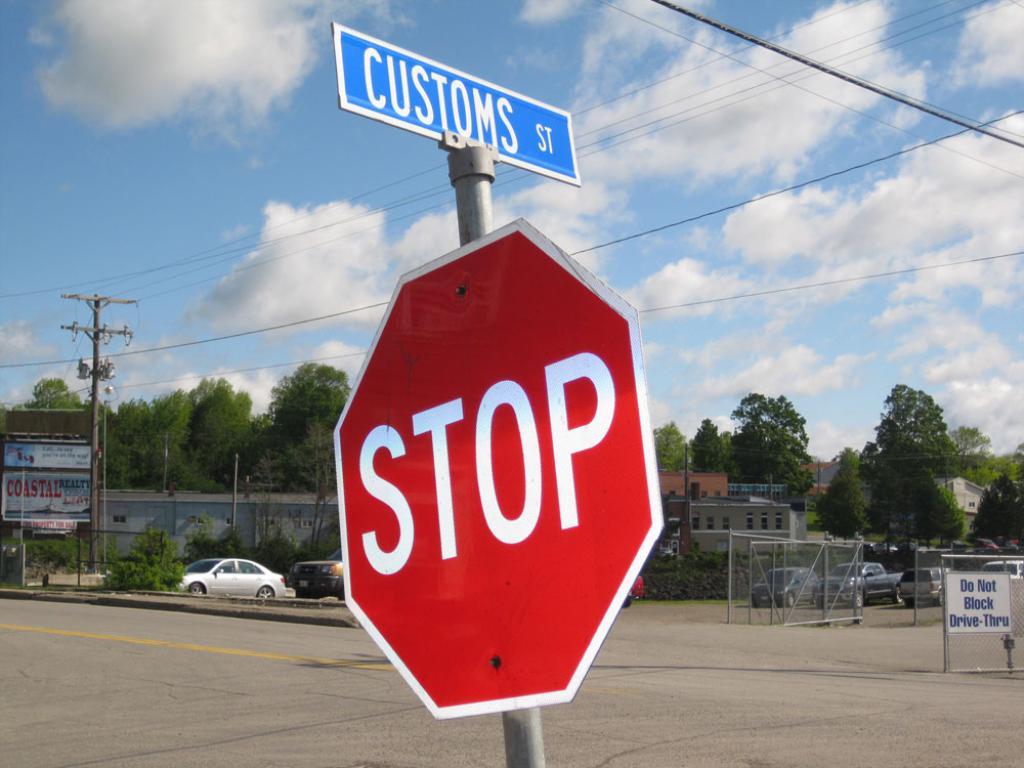What road is this?
Make the answer very short. Customs st. Is there a stop sign under the customs street sign?
Provide a succinct answer. Yes. 